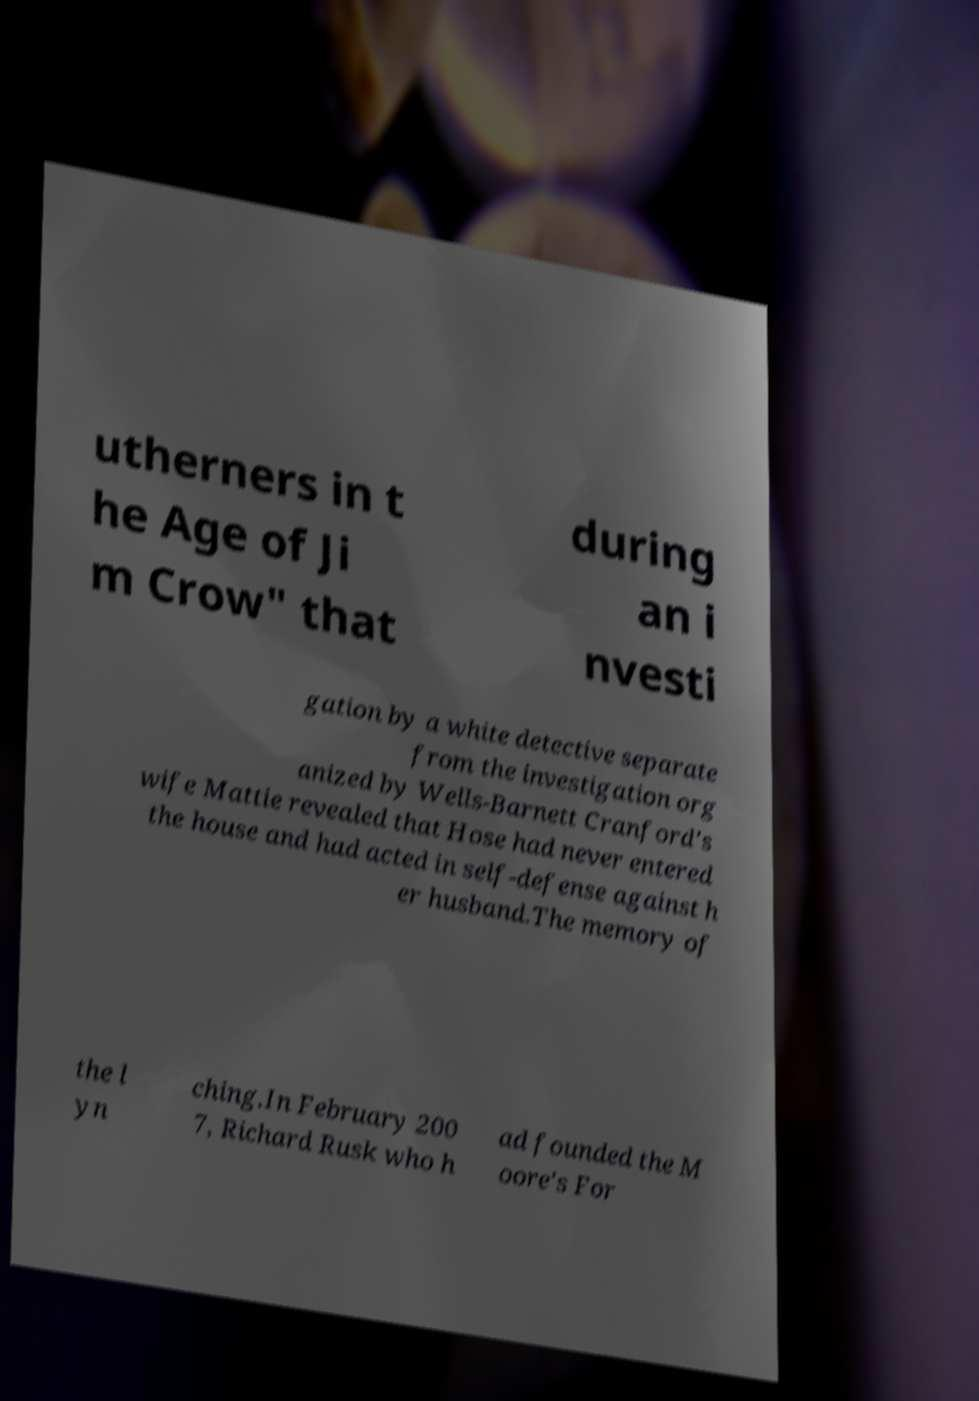Please identify and transcribe the text found in this image. utherners in t he Age of Ji m Crow" that during an i nvesti gation by a white detective separate from the investigation org anized by Wells-Barnett Cranford's wife Mattie revealed that Hose had never entered the house and had acted in self-defense against h er husband.The memory of the l yn ching.In February 200 7, Richard Rusk who h ad founded the M oore's For 